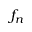Convert formula to latex. <formula><loc_0><loc_0><loc_500><loc_500>f _ { n }</formula> 